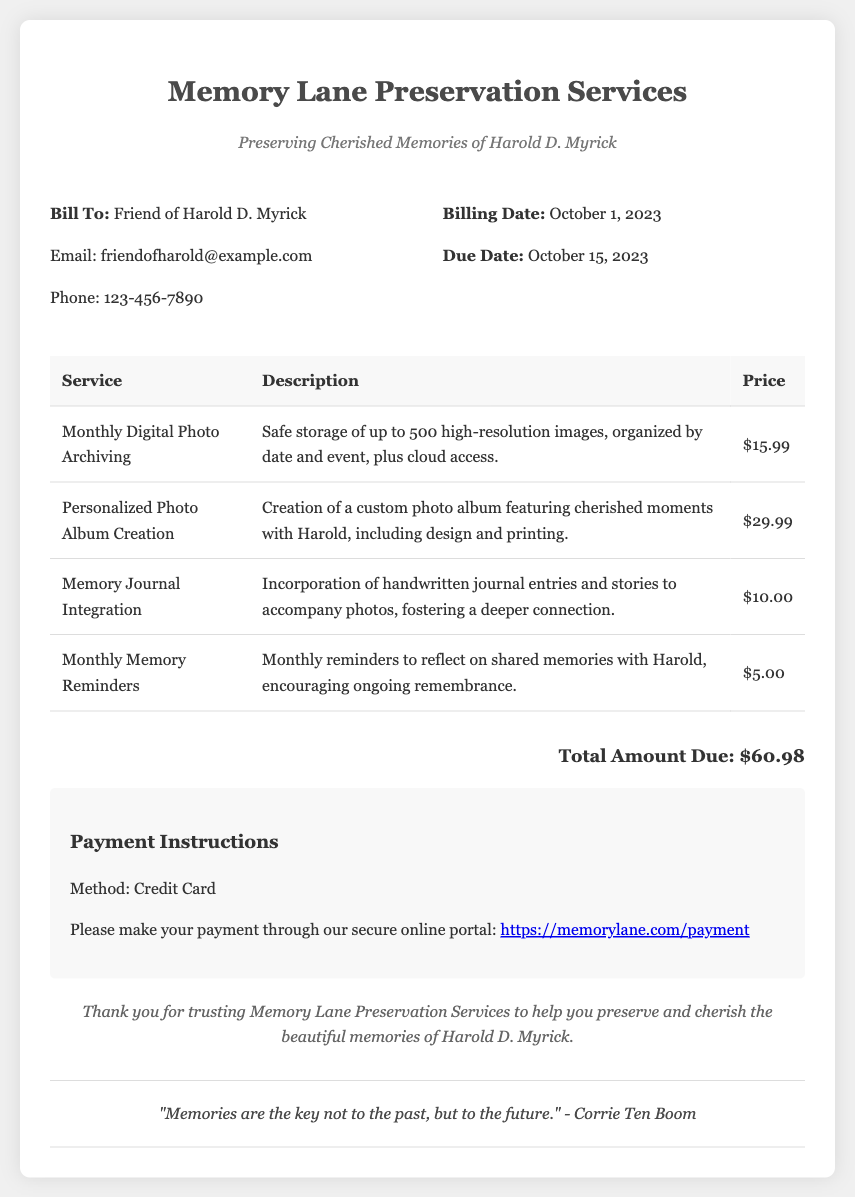What is the billing date? The billing date is mentioned under the bill info section of the document.
Answer: October 1, 2023 What is the total amount due? The total amount due is calculated based on the prices of the services listed in the table.
Answer: $60.98 What service includes cloud access? This information can be found in the description of the corresponding service in the document.
Answer: Monthly Digital Photo Archiving Who is the bill addressed to? The recipient's information is provided in the "Bill To" section of the document.
Answer: Friend of Harold D. Myrick What is included in the Personalized Photo Album Creation? This information is provided in the description of the specific service in the table.
Answer: Custom photo album featuring cherished moments with Harold How many high-resolution images are stored in the Monthly Digital Photo Archiving? The number of images is specified in the service description in the document.
Answer: 500 What is the purpose of Monthly Memory Reminders? The purpose is described in the details of that specific service in the bill.
Answer: Encouraging ongoing remembrance What method is used for payment? The payment method is indicated in the payment instructions section of the document.
Answer: Credit Card 